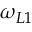<formula> <loc_0><loc_0><loc_500><loc_500>\omega _ { L 1 }</formula> 